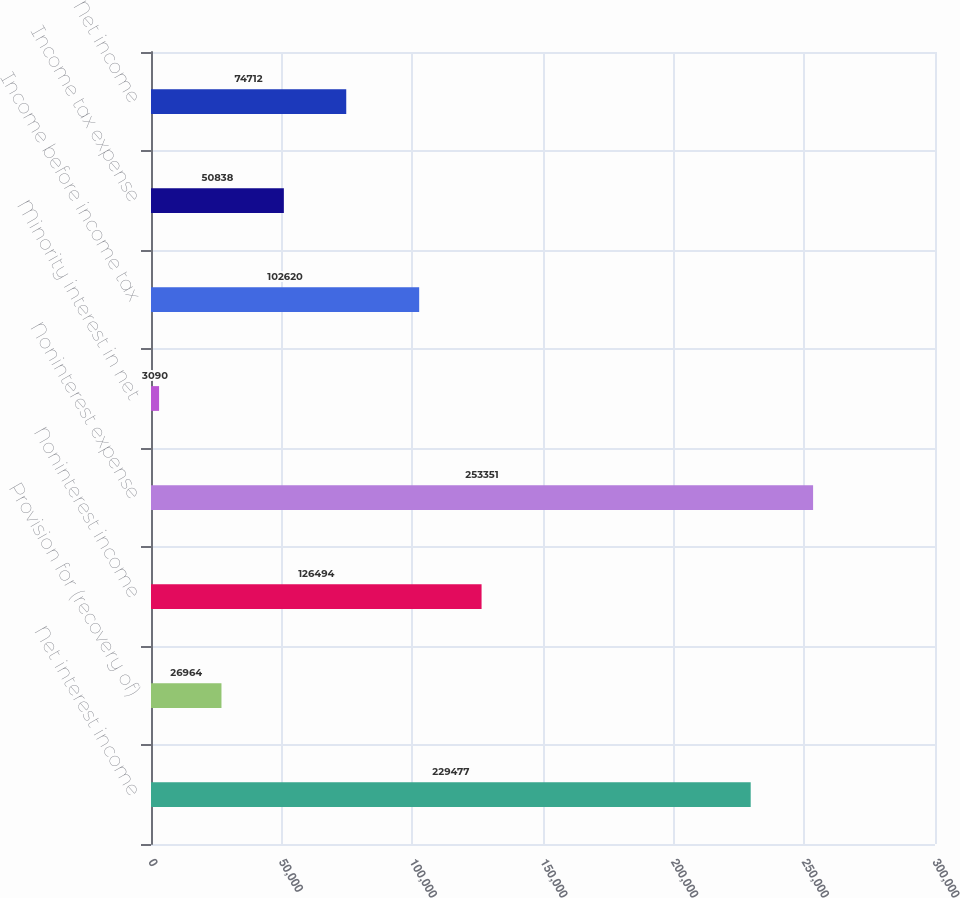Convert chart. <chart><loc_0><loc_0><loc_500><loc_500><bar_chart><fcel>Net interest income<fcel>Provision for (recovery of)<fcel>Noninterest income<fcel>Noninterest expense<fcel>Minority interest in net<fcel>Income before income tax<fcel>Income tax expense<fcel>Net income<nl><fcel>229477<fcel>26964<fcel>126494<fcel>253351<fcel>3090<fcel>102620<fcel>50838<fcel>74712<nl></chart> 